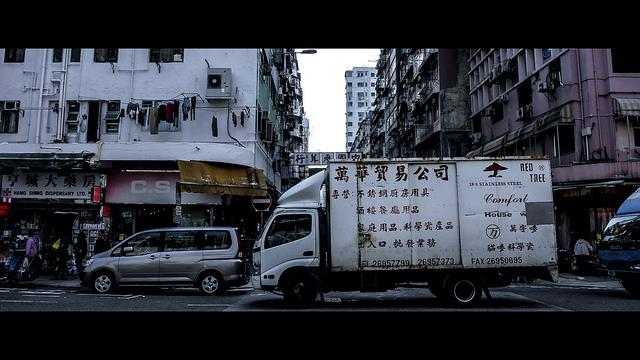Why does the large truck stop here?

Choices:
A) fixing vehicle
B) traffic
C) truck broken
D) to advertise traffic 